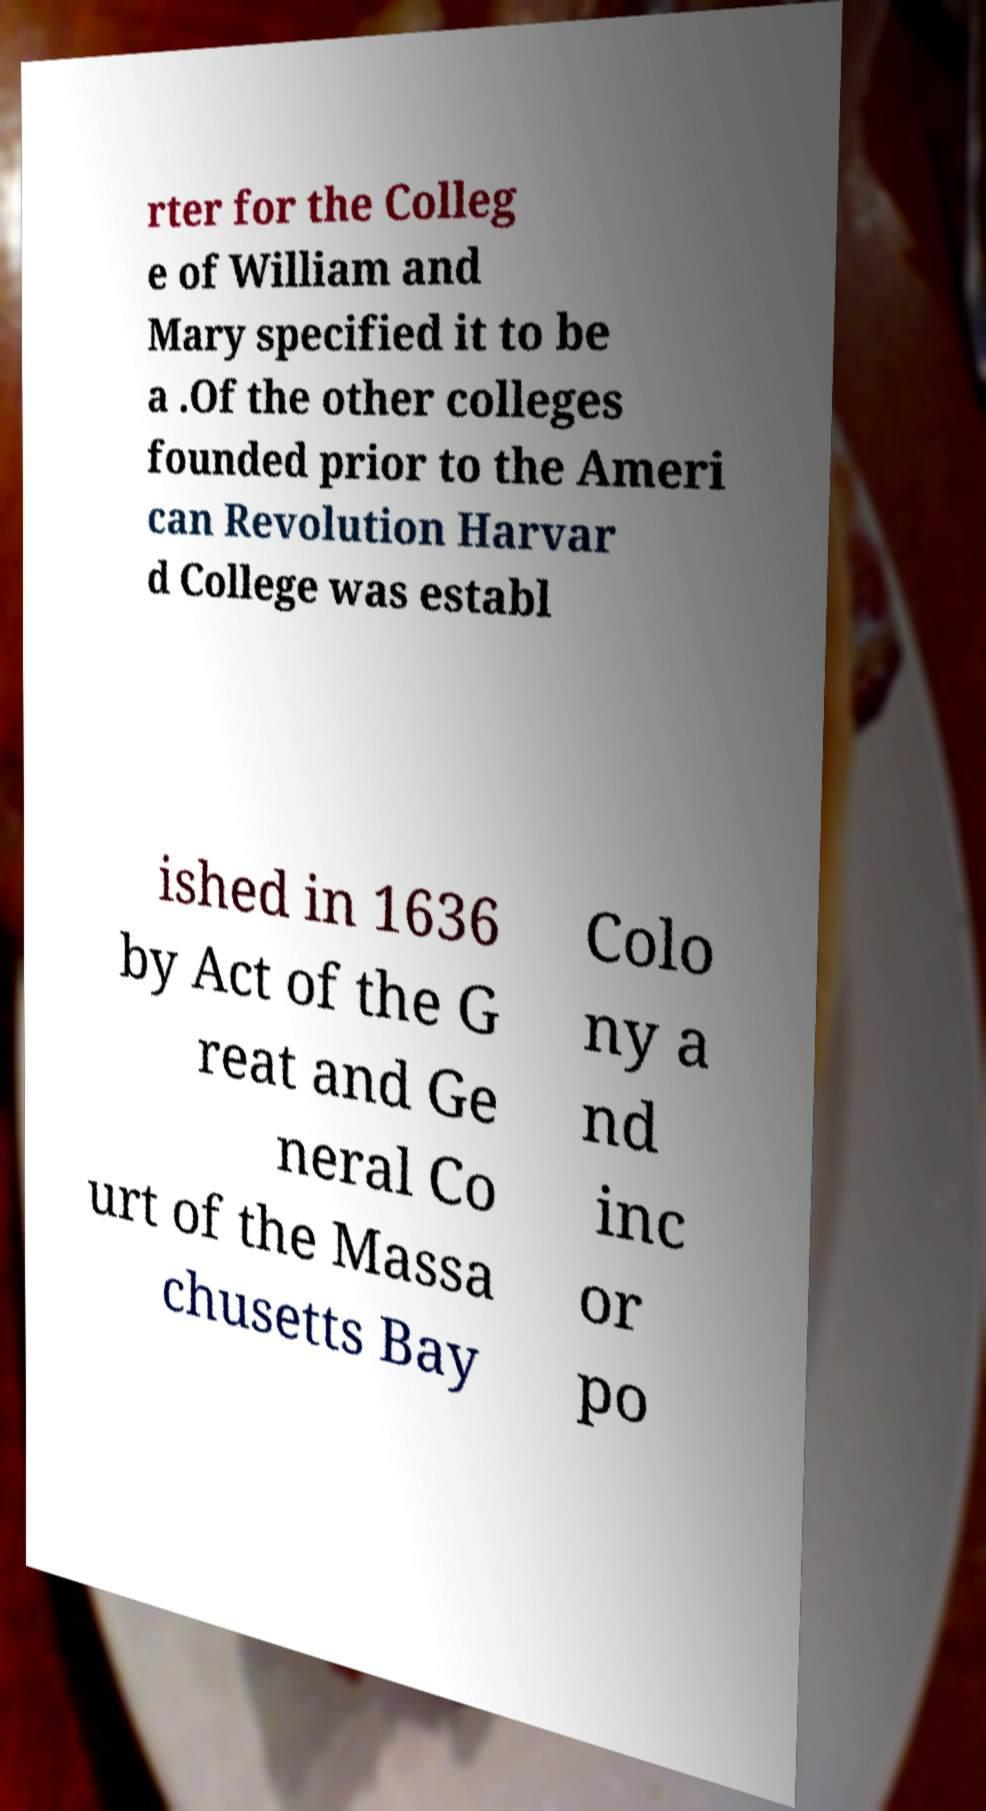Could you extract and type out the text from this image? rter for the Colleg e of William and Mary specified it to be a .Of the other colleges founded prior to the Ameri can Revolution Harvar d College was establ ished in 1636 by Act of the G reat and Ge neral Co urt of the Massa chusetts Bay Colo ny a nd inc or po 